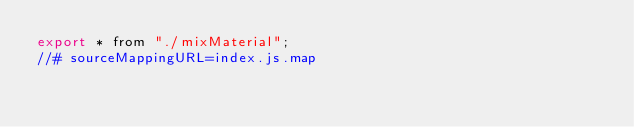Convert code to text. <code><loc_0><loc_0><loc_500><loc_500><_JavaScript_>export * from "./mixMaterial";
//# sourceMappingURL=index.js.map</code> 